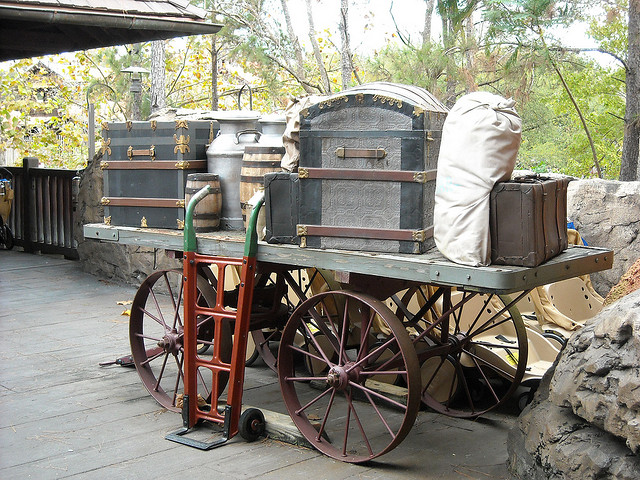What might the contents of the trunks and containers be? Given the historical context suggested by the wagon, the trunks and containers could hold personal belongings, supplies for travel, such as clothing, tools, or dried foods, akin to what pioneers or travelers might have carried during long journeys. 